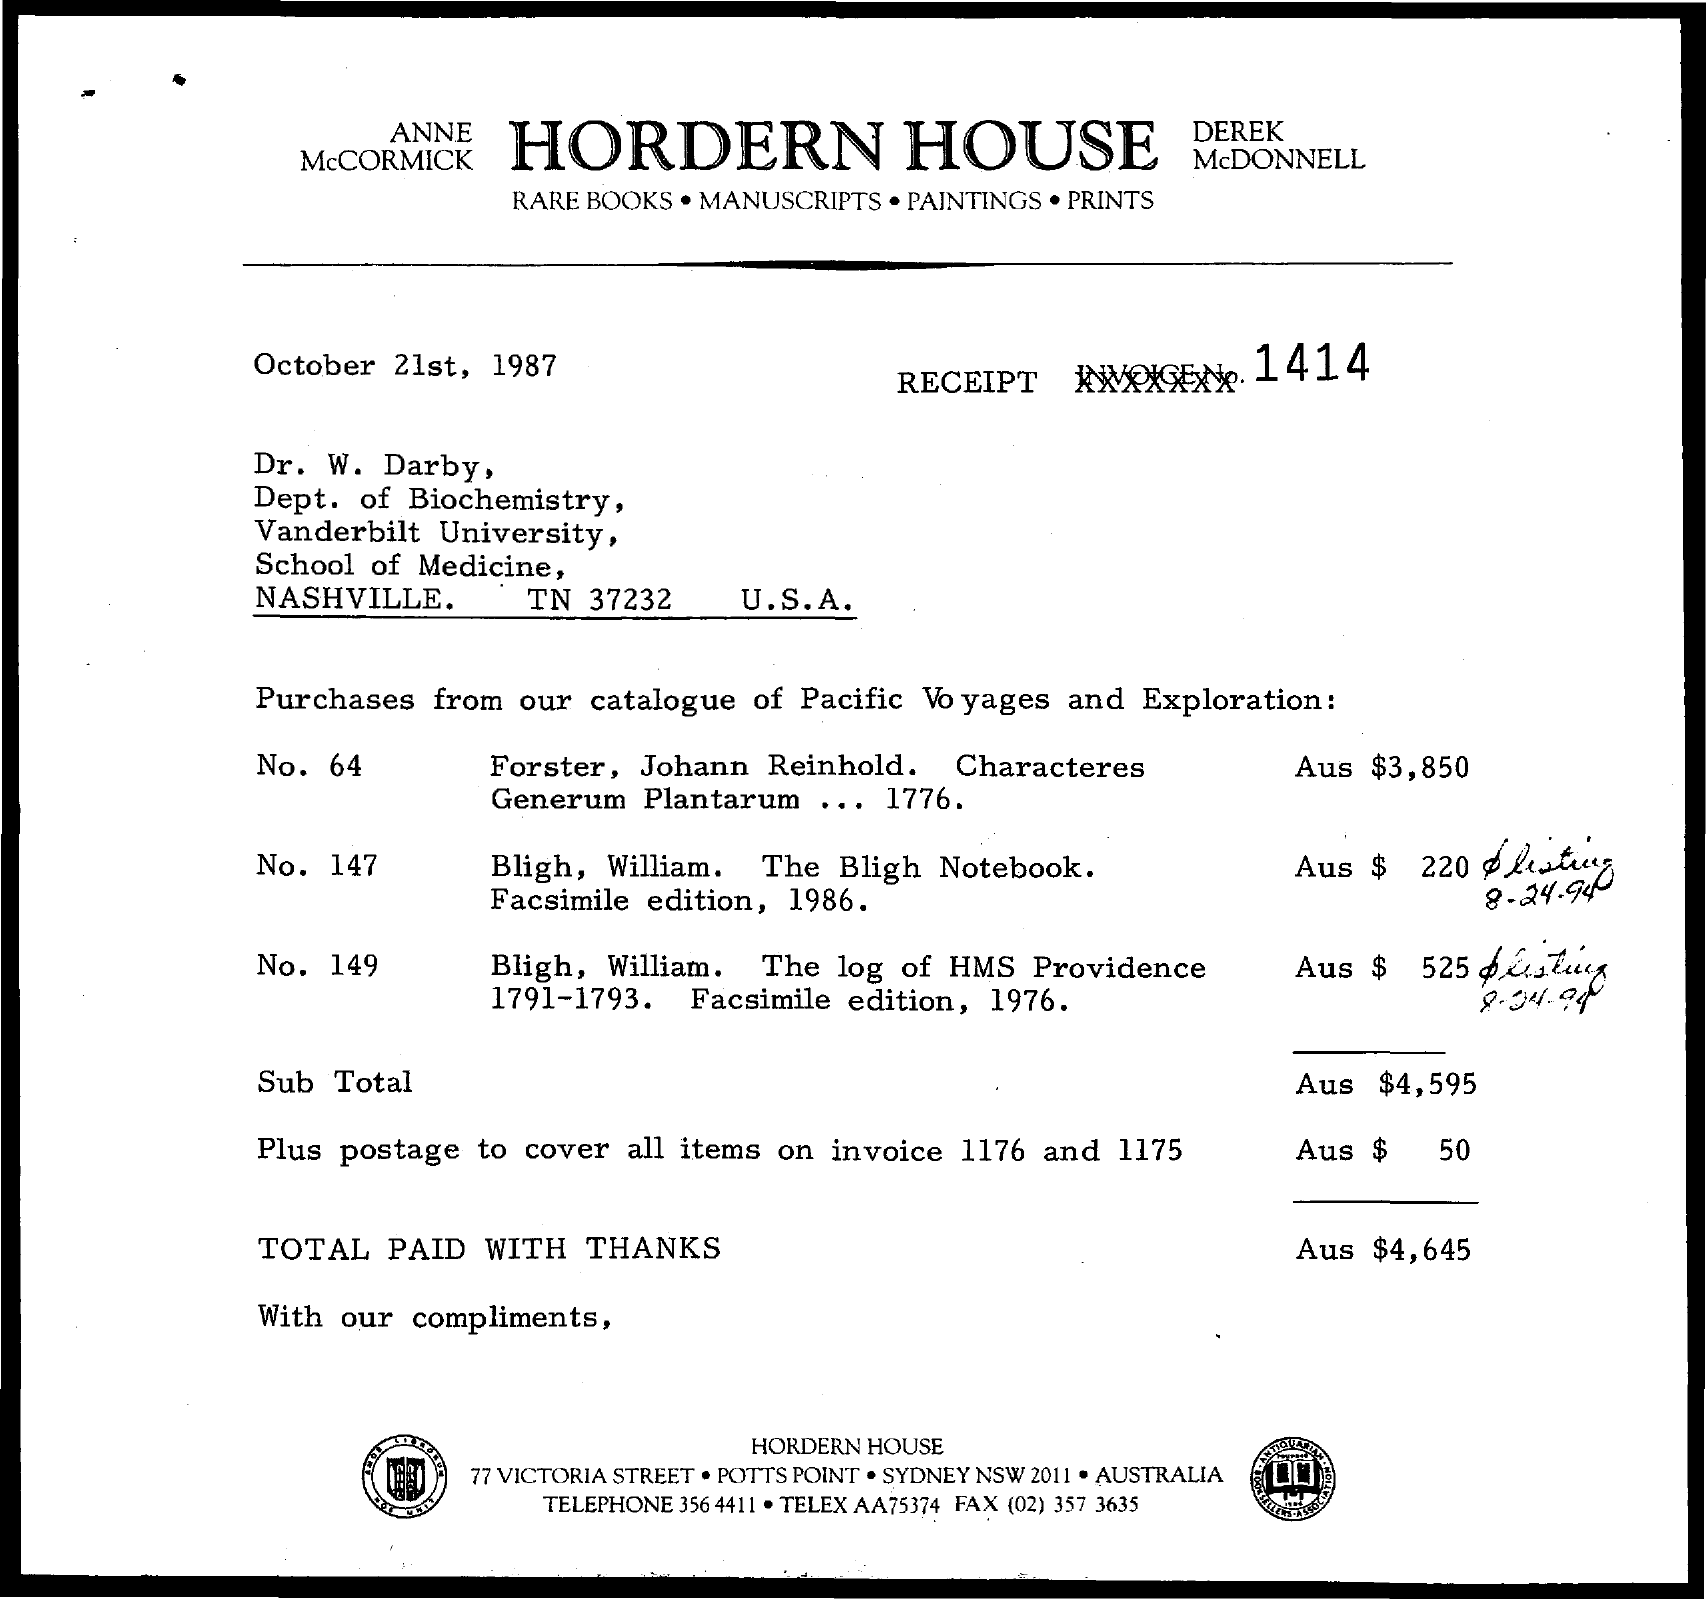Give some essential details in this illustration. Hordern House's fax number is (02) 357 3635. The total amount is AUS $4,645. Hordern House's telephone number is 356 4411. The total amount charged for postage to cover all items on invoices 1176 and 1175 is AUD $50. Dr. W. Darby belongs to the Department of Biochemistry. 